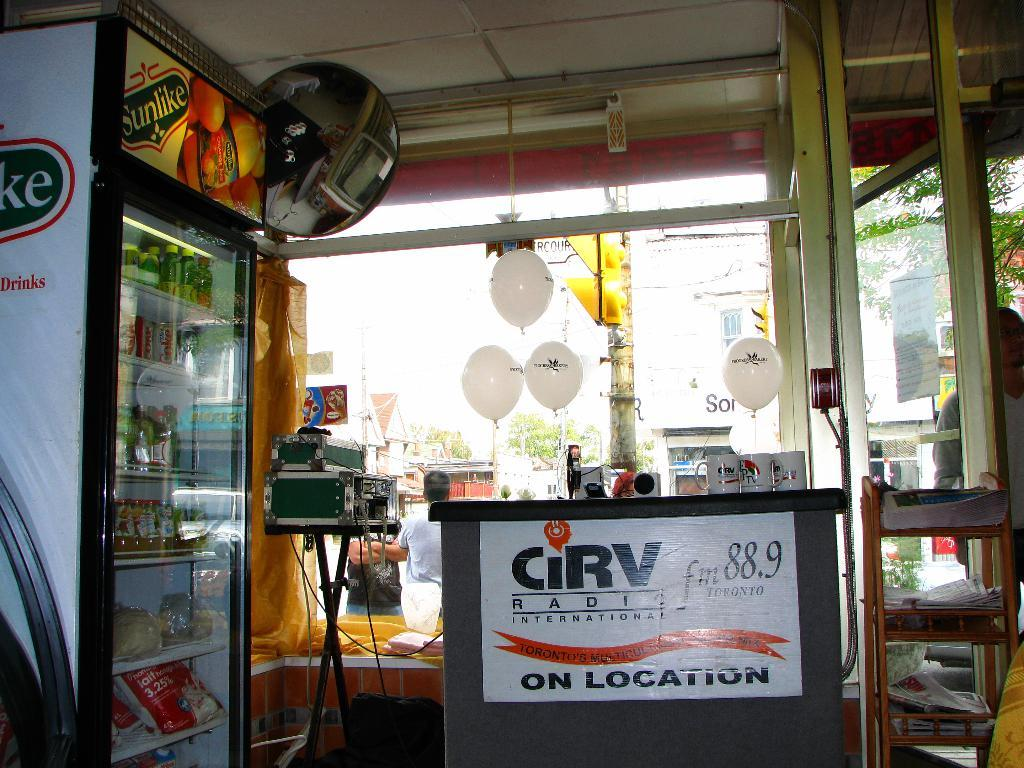<image>
Create a compact narrative representing the image presented. A banner for CiRV Radio International hangs beneath a counter with white balloons 